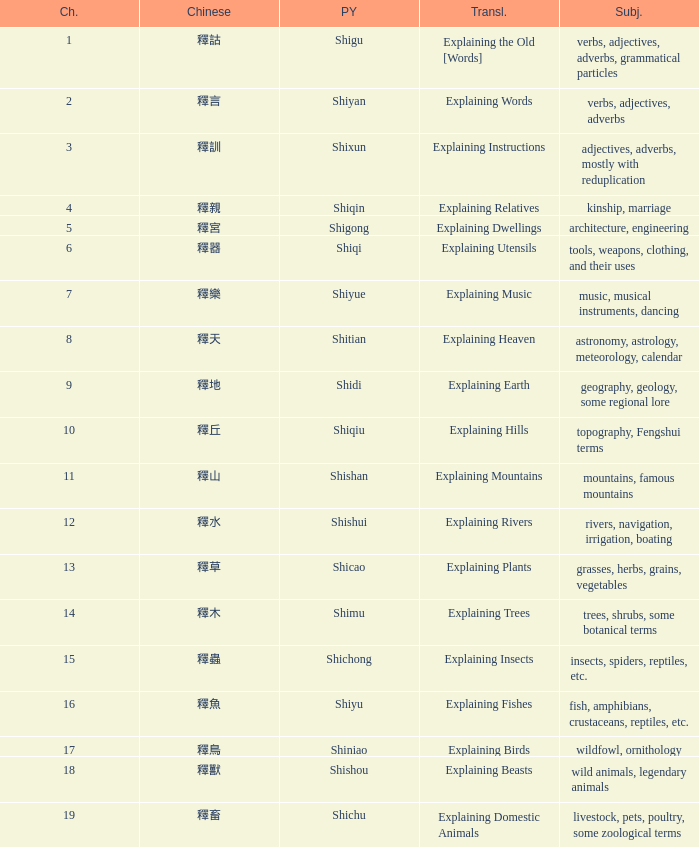Name the highest chapter with chinese of 釋言 2.0. 